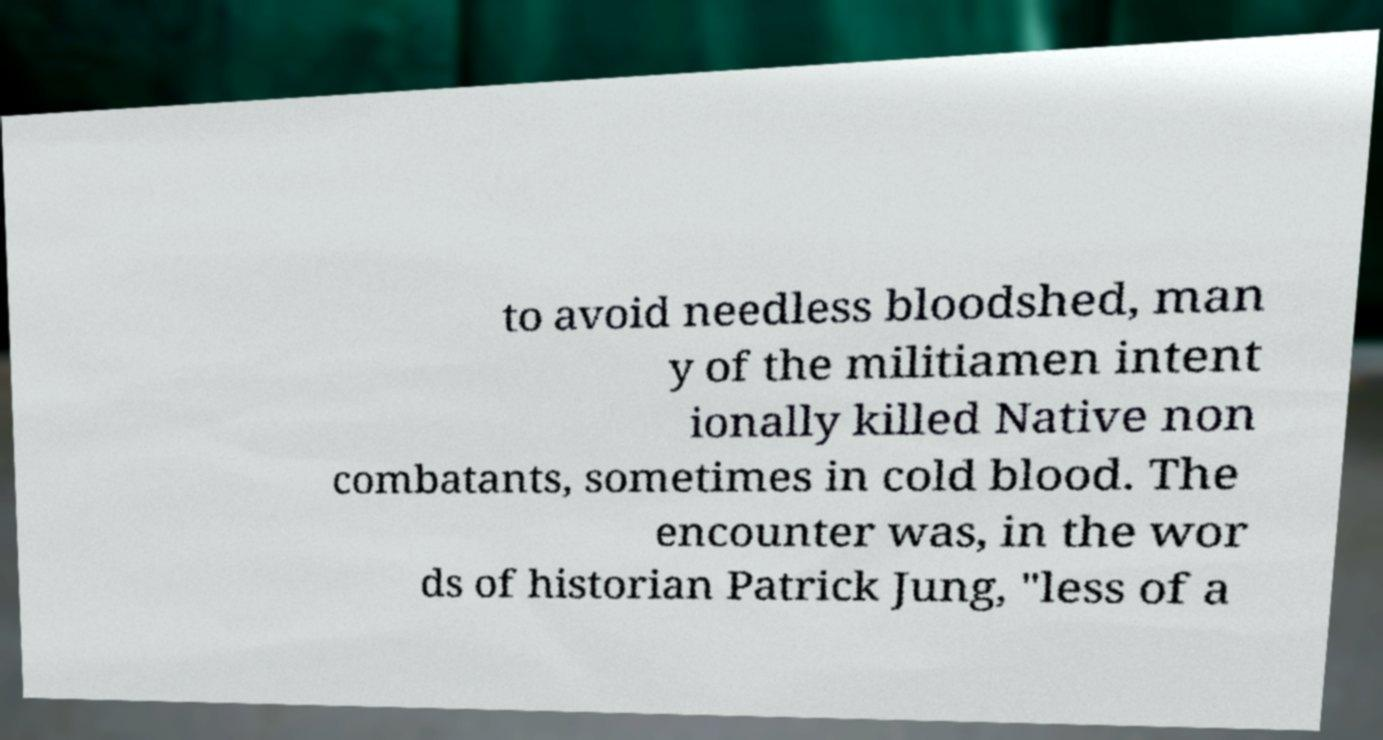Can you accurately transcribe the text from the provided image for me? to avoid needless bloodshed, man y of the militiamen intent ionally killed Native non combatants, sometimes in cold blood. The encounter was, in the wor ds of historian Patrick Jung, "less of a 